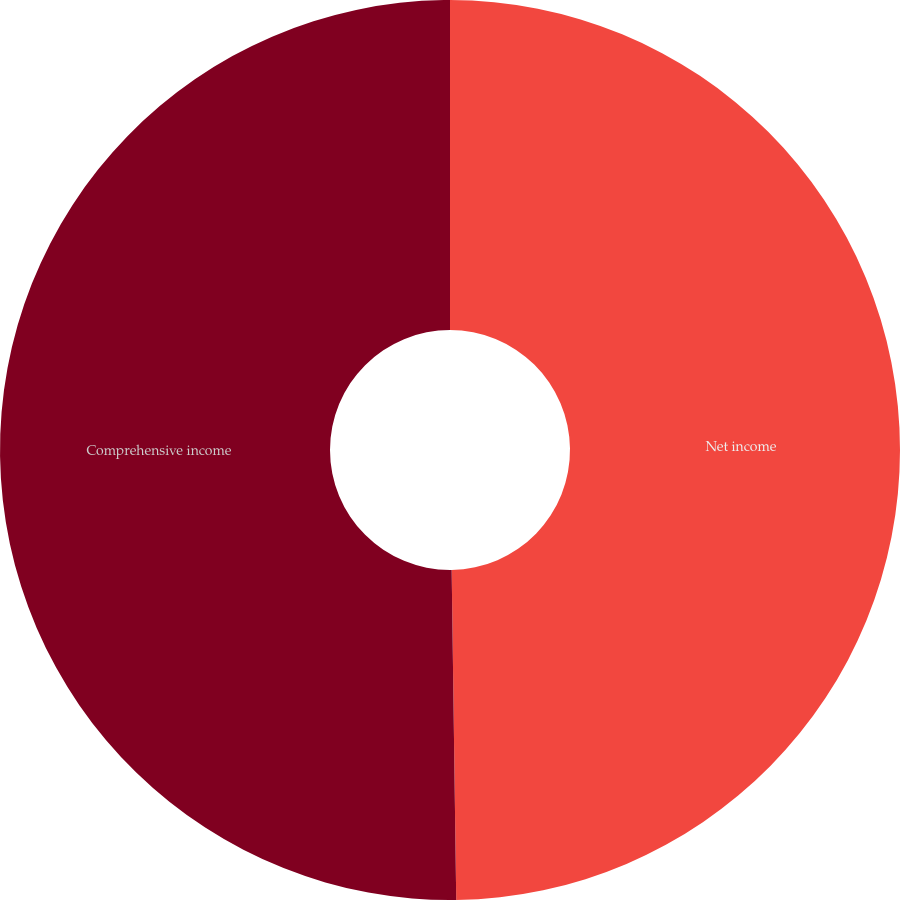Convert chart to OTSL. <chart><loc_0><loc_0><loc_500><loc_500><pie_chart><fcel>Net income<fcel>Comprehensive income<nl><fcel>49.78%<fcel>50.22%<nl></chart> 